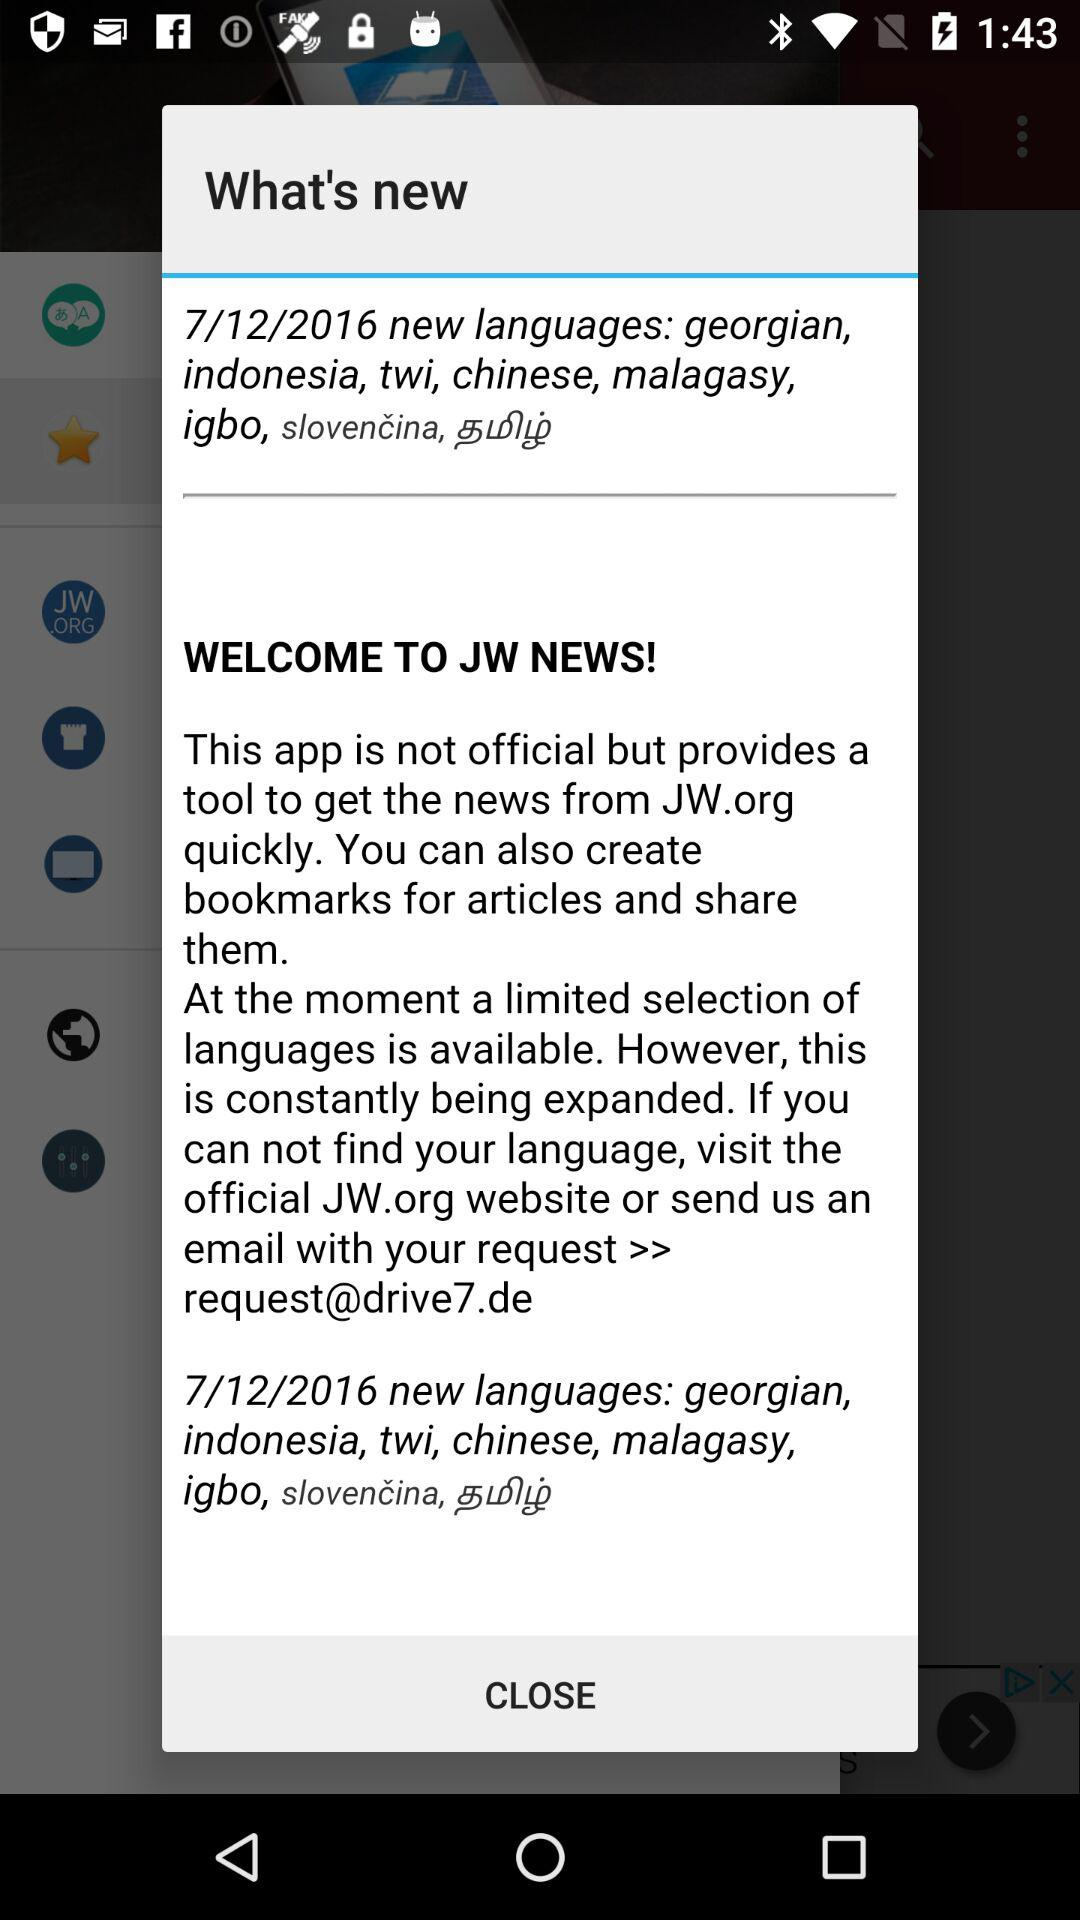When was the new language updated? The new language was updated on 7/12/2016. 